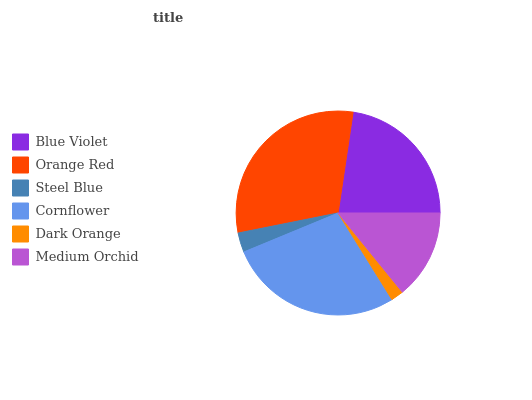Is Dark Orange the minimum?
Answer yes or no. Yes. Is Orange Red the maximum?
Answer yes or no. Yes. Is Steel Blue the minimum?
Answer yes or no. No. Is Steel Blue the maximum?
Answer yes or no. No. Is Orange Red greater than Steel Blue?
Answer yes or no. Yes. Is Steel Blue less than Orange Red?
Answer yes or no. Yes. Is Steel Blue greater than Orange Red?
Answer yes or no. No. Is Orange Red less than Steel Blue?
Answer yes or no. No. Is Blue Violet the high median?
Answer yes or no. Yes. Is Medium Orchid the low median?
Answer yes or no. Yes. Is Cornflower the high median?
Answer yes or no. No. Is Orange Red the low median?
Answer yes or no. No. 